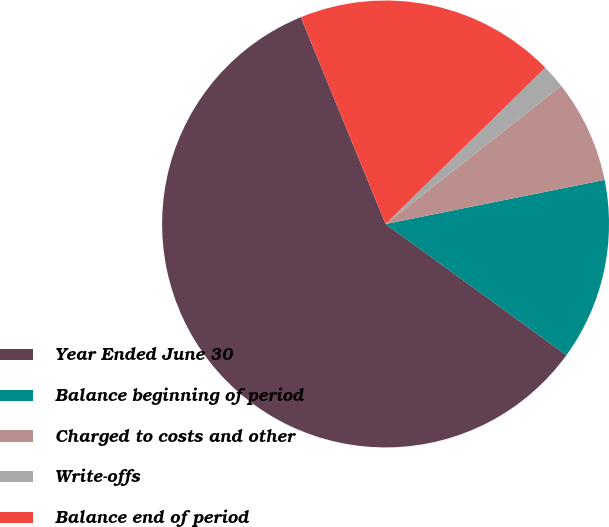Convert chart to OTSL. <chart><loc_0><loc_0><loc_500><loc_500><pie_chart><fcel>Year Ended June 30<fcel>Balance beginning of period<fcel>Charged to costs and other<fcel>Write-offs<fcel>Balance end of period<nl><fcel>58.83%<fcel>13.15%<fcel>7.44%<fcel>1.73%<fcel>18.86%<nl></chart> 